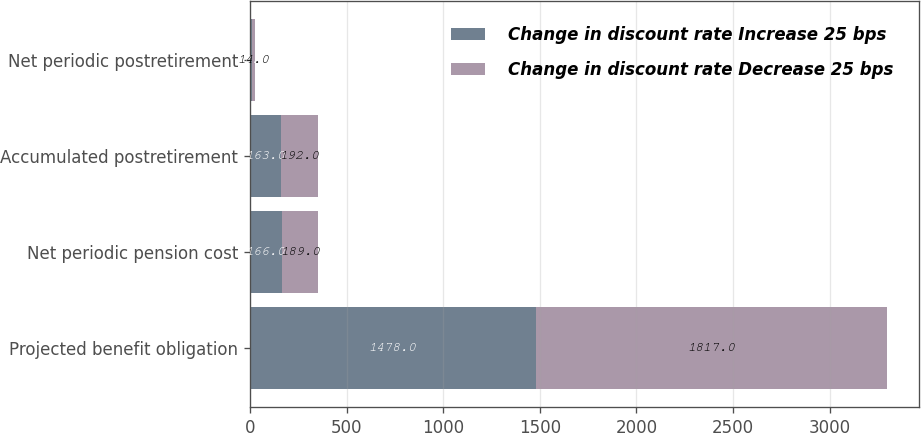<chart> <loc_0><loc_0><loc_500><loc_500><stacked_bar_chart><ecel><fcel>Projected benefit obligation<fcel>Net periodic pension cost<fcel>Accumulated postretirement<fcel>Net periodic postretirement<nl><fcel>Change in discount rate Increase 25 bps<fcel>1478<fcel>166<fcel>163<fcel>12<nl><fcel>Change in discount rate Decrease 25 bps<fcel>1817<fcel>189<fcel>192<fcel>14<nl></chart> 